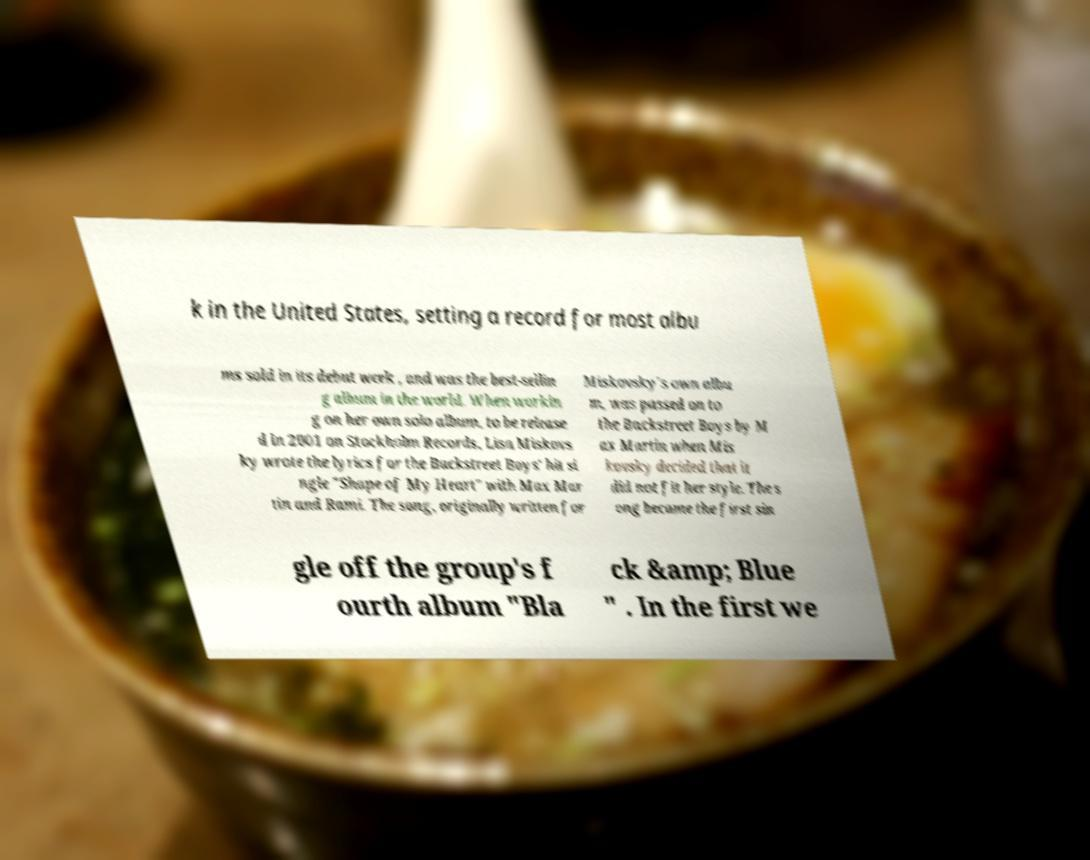Please identify and transcribe the text found in this image. k in the United States, setting a record for most albu ms sold in its debut week , and was the best-sellin g album in the world. When workin g on her own solo album, to be release d in 2001 on Stockholm Records, Lisa Miskovs ky wrote the lyrics for the Backstreet Boys' hit si ngle "Shape of My Heart" with Max Mar tin and Rami. The song, originally written for Miskovsky's own albu m, was passed on to the Backstreet Boys by M ax Martin when Mis kovsky decided that it did not fit her style. The s ong became the first sin gle off the group's f ourth album "Bla ck &amp; Blue " . In the first we 